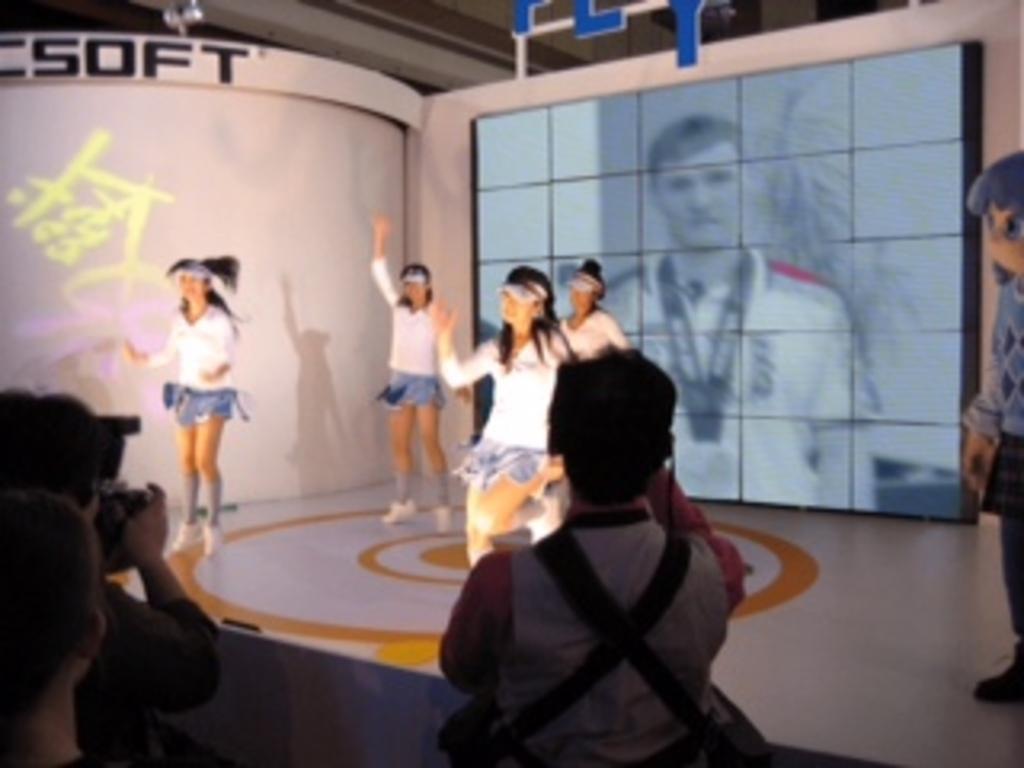Describe this image in one or two sentences. In this image, we can see few people. Few are dancing on the floor. Background there is a screen. On the left side of the image, a person is holding a camera. 